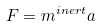Convert formula to latex. <formula><loc_0><loc_0><loc_500><loc_500>F = m ^ { i n e r t } a</formula> 